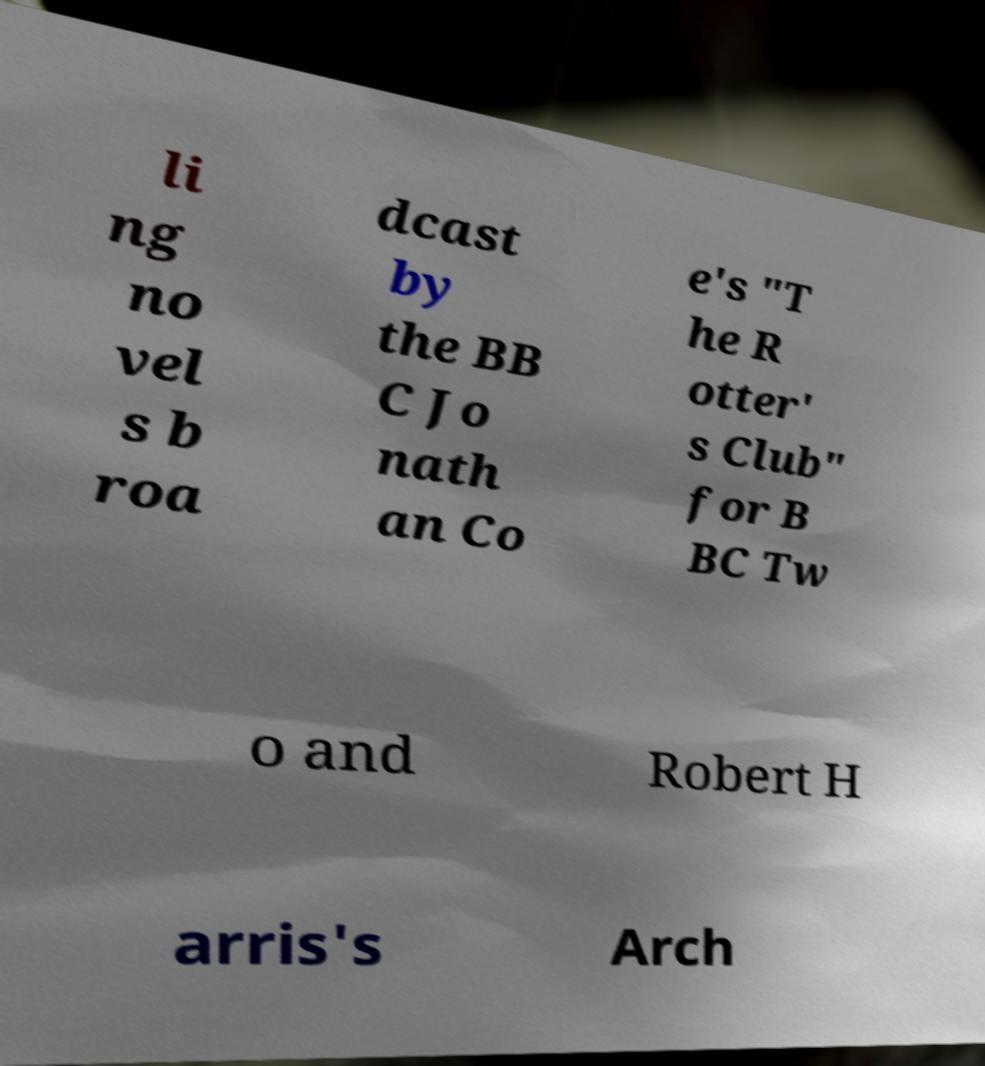Can you read and provide the text displayed in the image?This photo seems to have some interesting text. Can you extract and type it out for me? li ng no vel s b roa dcast by the BB C Jo nath an Co e's "T he R otter' s Club" for B BC Tw o and Robert H arris's Arch 